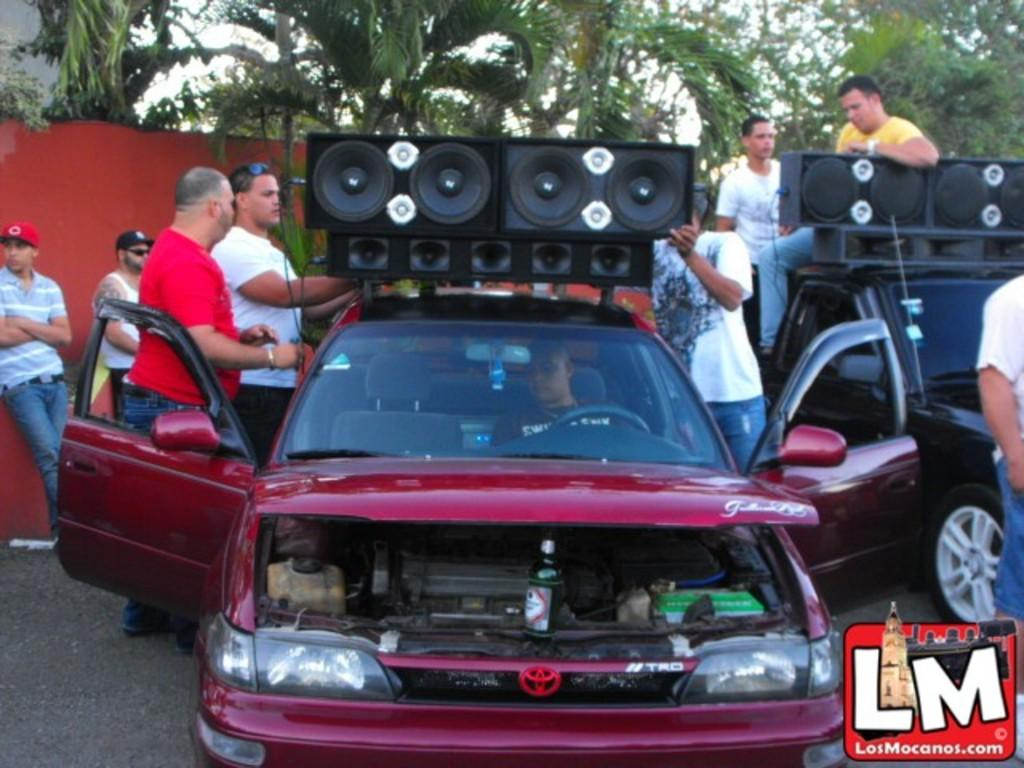What is the main subject in the center of the image? There is a car in the center of the image. Who is inside the car? There is a person sitting in the car. What are the people around the car doing? The people are grouped around the car and holding a speaker. What can be seen in the background of the image? There are trees visible in the background. How many girls are sitting on the furniture in the image? There is no furniture or girls present in the image. 